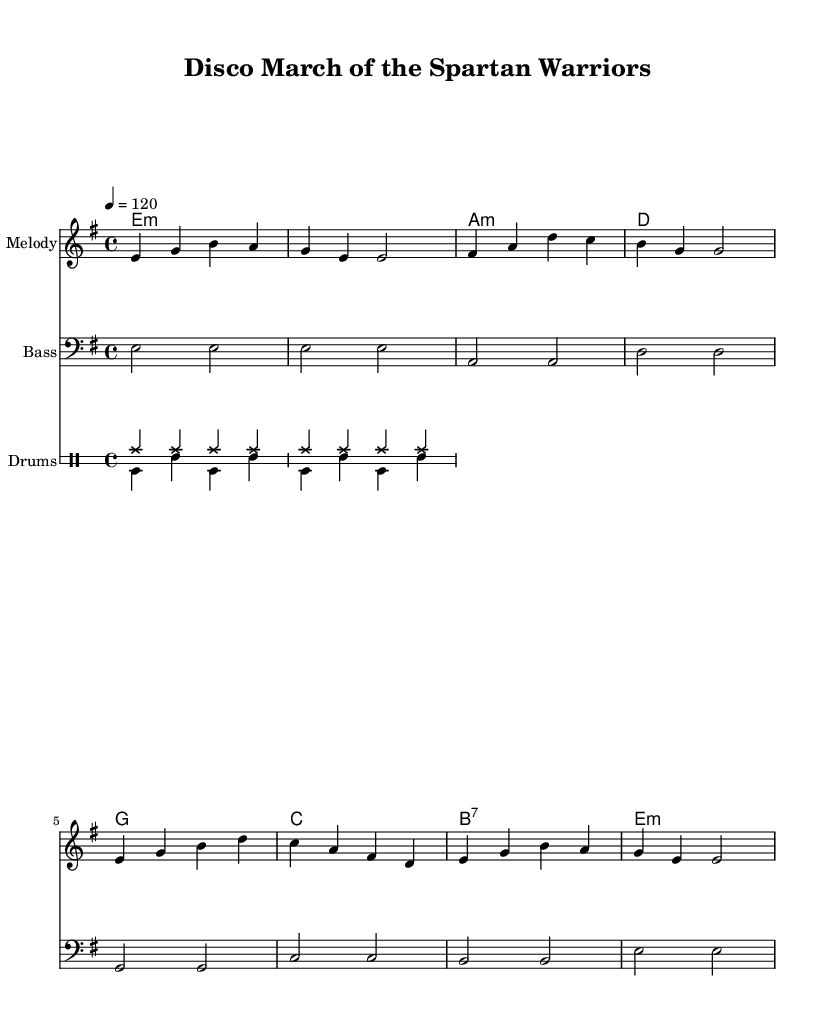What is the key signature of this music? The key signature is E minor, which has one sharp (F#). It is indicated at the beginning of the sheet music before the time signature.
Answer: E minor What is the time signature of this music? The time signature is 4/4, meaning there are four beats in each measure and the quarter note gets one beat. This is indicated at the beginning of the sheet music next to the key signature.
Answer: 4/4 What is the tempo marking for this piece? The tempo marking is 120 beats per minute, indicated by the tempo instruction "4 = 120" at the start. This tells musicians the speed at which to perform the piece.
Answer: 120 What type of drums are used in the rhythm section? The rhythm section features a hi-hat and bass drum, as indicated in the drumming notation. The hi-hat is shown as "hihat" and the bass drum as "bd" when noted.
Answer: Hi-hat and bass drum How many measures does the melody contain? The melody consists of 8 measures, counting each grouping of notes between the vertical bar lines in the melody staff.
Answer: 8 What harmony is played during the last measure? The harmony in the last measure is E minor, indicated by the chord symbol "e:m" placed above the staff. This shows the type of chord played alongside the melody.
Answer: E minor What is a distinctive feature of this Disco arrangement of a war march? A distinctive feature is the use of a disco beat with a steady bass and hi-hat patterns, providing a danceable rhythm that contrasts with the traditional military feel. It is a blending of genres that energizes the original march.
Answer: Disco beat 